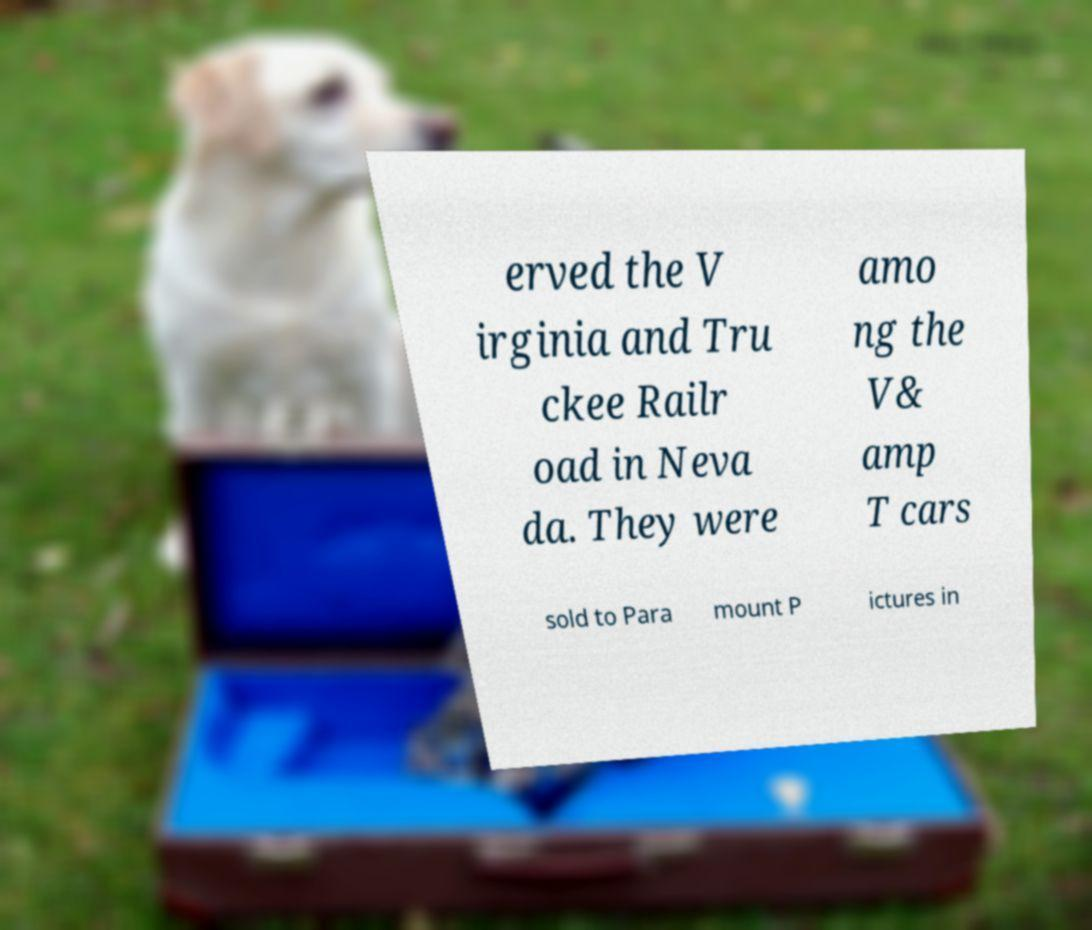There's text embedded in this image that I need extracted. Can you transcribe it verbatim? erved the V irginia and Tru ckee Railr oad in Neva da. They were amo ng the V& amp T cars sold to Para mount P ictures in 